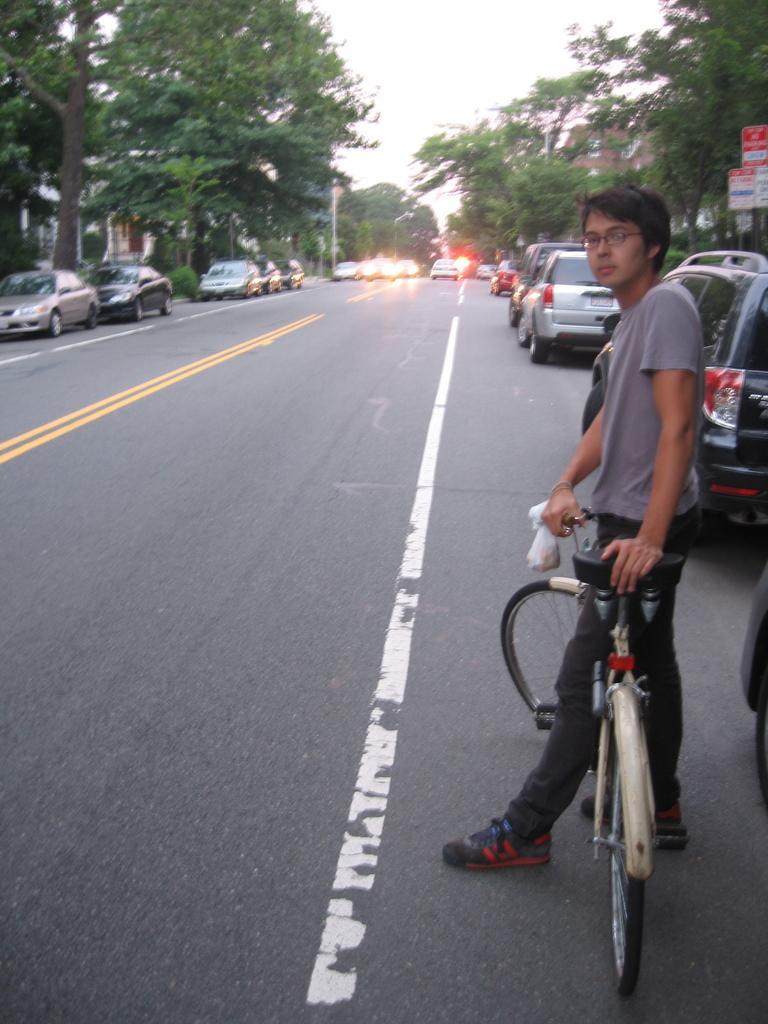Describe this image in one or two sentences. He is standing on a roadside. He's holding a bicycle seat. We can see in the background there is a sky,tree and vehicle. 